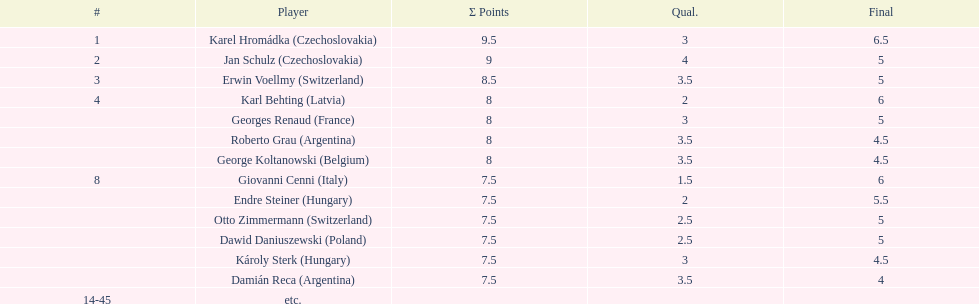How many countries had more than one player in the consolation cup? 4. 